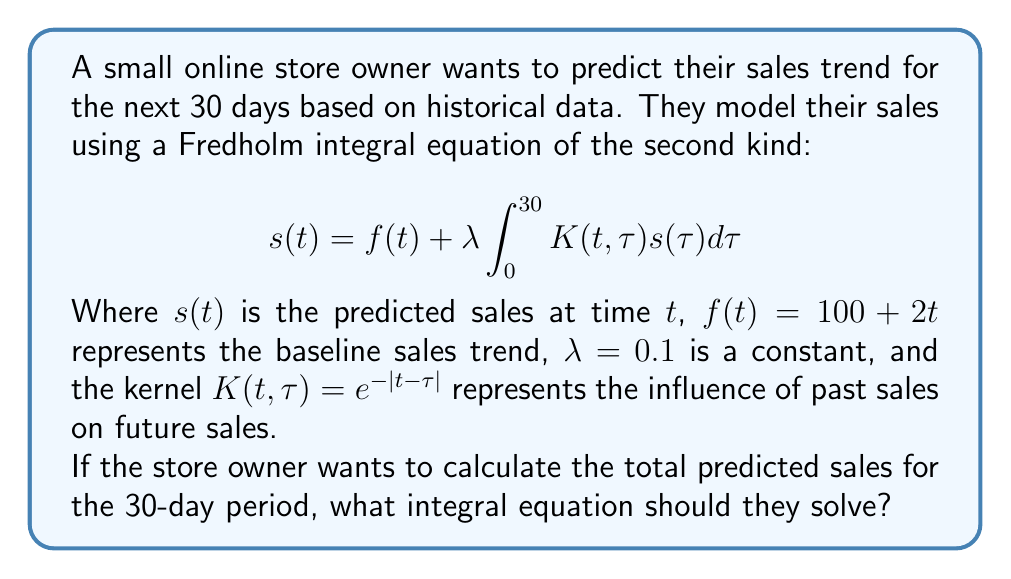Show me your answer to this math problem. To solve this problem, we need to follow these steps:

1) The total predicted sales for the 30-day period is the integral of $s(t)$ from 0 to 30:

   $$\text{Total Sales} = \int_0^{30} s(t)dt$$

2) We substitute the given Fredholm integral equation for $s(t)$:

   $$\int_0^{30} s(t)dt = \int_0^{30} \left(f(t) + \lambda \int_0^{30} K(t,\tau)s(\tau)d\tau\right)dt$$

3) We can split this into two integrals:

   $$\int_0^{30} s(t)dt = \int_0^{30} f(t)dt + \lambda \int_0^{30} \left(\int_0^{30} K(t,\tau)s(\tau)d\tau\right)dt$$

4) The first integral is straightforward:

   $$\int_0^{30} f(t)dt = \int_0^{30} (100 + 2t)dt = [100t + t^2]_0^{30} = 3900$$

5) For the second integral, we can change the order of integration:

   $$\lambda \int_0^{30} \left(\int_0^{30} K(t,\tau)s(\tau)d\tau\right)dt = \lambda \int_0^{30} \left(\int_0^{30} K(t,\tau)dt\right)s(\tau)d\tau$$

6) Let's define a new function:

   $$g(\tau) = \int_0^{30} K(t,\tau)dt = \int_0^{30} e^{-|t-\tau|}dt$$

7) Now our equation becomes:

   $$\int_0^{30} s(t)dt = 3900 + \lambda \int_0^{30} g(\tau)s(\tau)d\tau$$

This is the integral equation that the store owner should solve to calculate the total predicted sales for the 30-day period.
Answer: $$\int_0^{30} s(t)dt = 3900 + 0.1 \int_0^{30} g(\tau)s(\tau)d\tau$$
where $g(\tau) = \int_0^{30} e^{-|t-\tau|}dt$ 